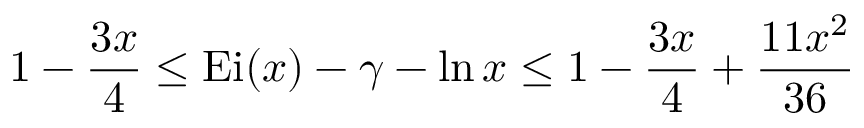Convert formula to latex. <formula><loc_0><loc_0><loc_500><loc_500>1 - { \frac { 3 x } { 4 } } \leq { E i } ( x ) - \gamma - \ln x \leq 1 - { \frac { 3 x } { 4 } } + { \frac { 1 1 x ^ { 2 } } { 3 6 } }</formula> 